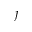Convert formula to latex. <formula><loc_0><loc_0><loc_500><loc_500>\jmath</formula> 